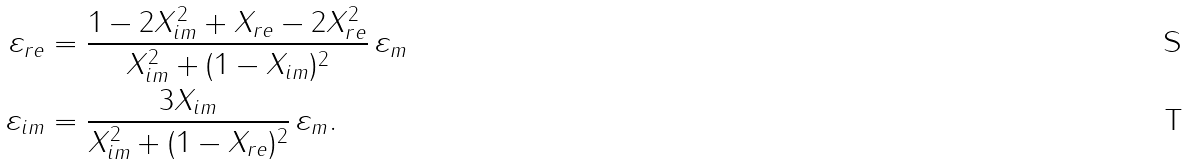Convert formula to latex. <formula><loc_0><loc_0><loc_500><loc_500>\varepsilon _ { r e } & = \frac { 1 - 2 X _ { i m } ^ { 2 } + X _ { r e } - 2 X _ { r e } ^ { 2 } } { X _ { i m } ^ { 2 } + ( 1 - X _ { i m } ) ^ { 2 } } \, \varepsilon _ { m } \\ \varepsilon _ { i m } & = \frac { 3 X _ { i m } } { X _ { i m } ^ { 2 } + ( 1 - X _ { r e } ) ^ { 2 } } \, \varepsilon _ { m } .</formula> 